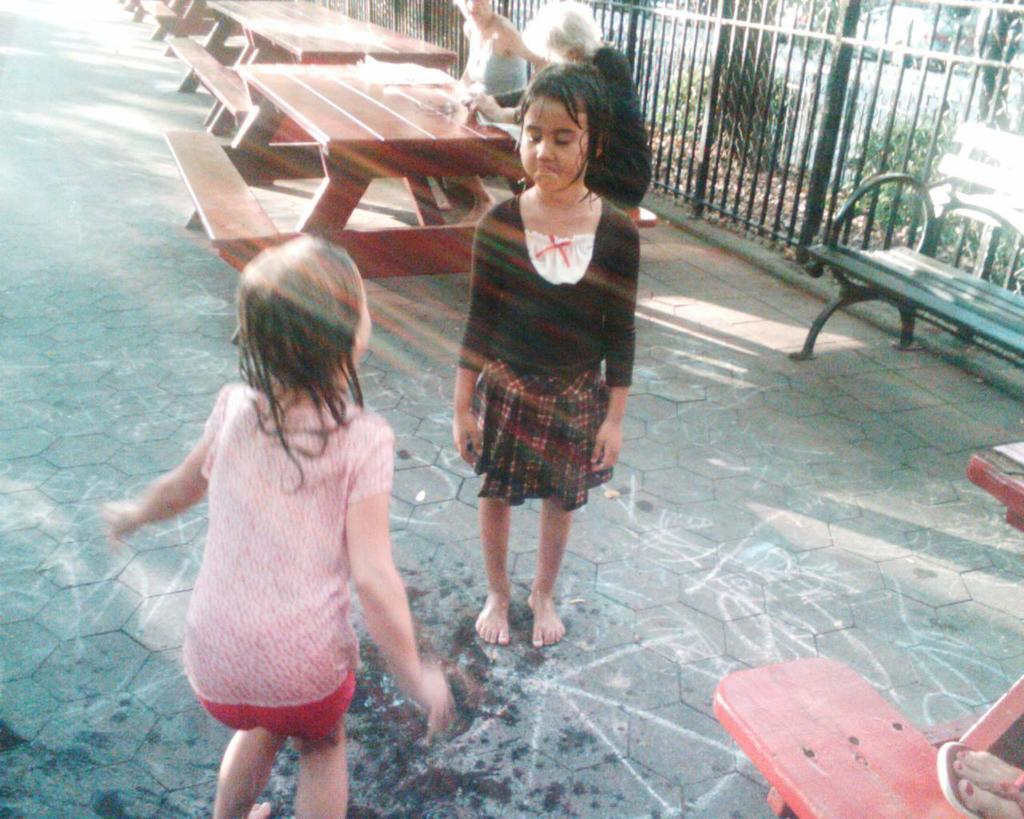How many baby girls are in the image? There are two baby girls in the image. What are the baby girls doing in the image? The baby girls are standing on a road. What is located behind the baby girls? There is a bench behind the baby girls. Who is sitting on the bench? There are ladies sitting on the bench. What type of jail can be seen in the image? There is no jail present in the image. What kind of treatment is being administered to the baby girls in the image? There is no treatment being administered to the baby girls in the image; they are simply standing on a road. 